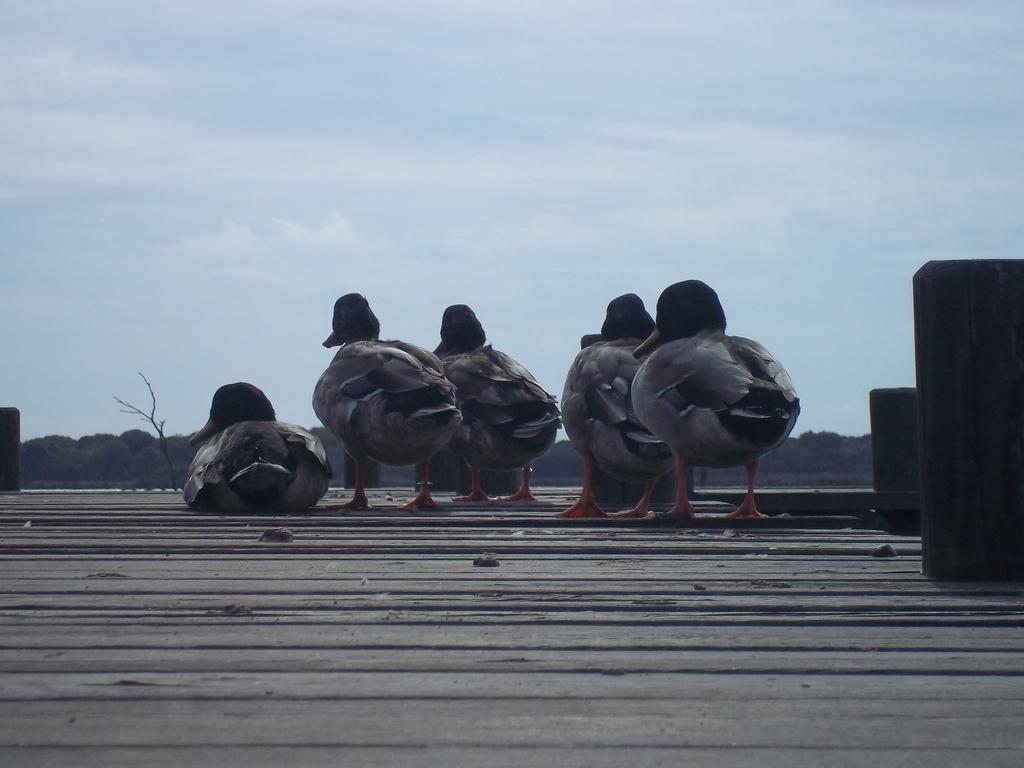Could you give a brief overview of what you see in this image? In this image there are ducks on a wooden surface, in the background there are trees and the sky. 